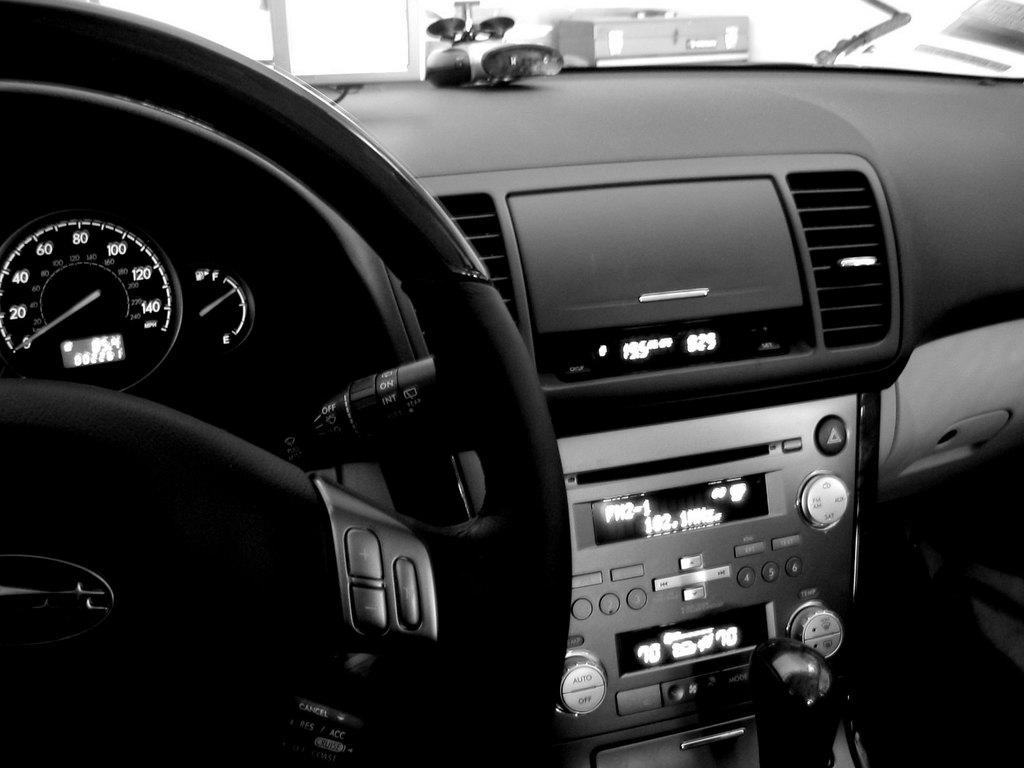What is the color scheme of the image? The image is black and white. What part of a car can be seen in the image? There is a car's dashboard in the image. How many flags are visible on the car's dashboard in the image? There are no flags visible on the car's dashboard in the image, as it is a black and white image and flags are not mentioned in the facts. 